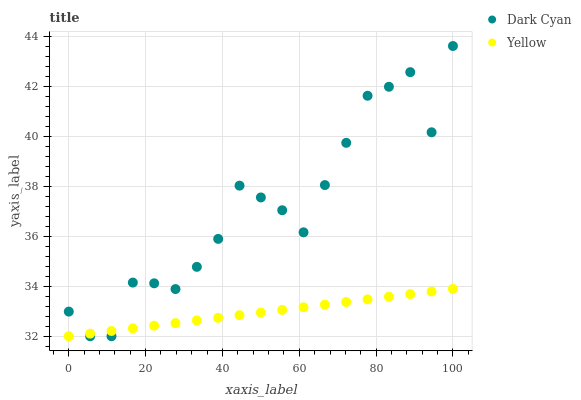Does Yellow have the minimum area under the curve?
Answer yes or no. Yes. Does Dark Cyan have the maximum area under the curve?
Answer yes or no. Yes. Does Yellow have the maximum area under the curve?
Answer yes or no. No. Is Yellow the smoothest?
Answer yes or no. Yes. Is Dark Cyan the roughest?
Answer yes or no. Yes. Is Yellow the roughest?
Answer yes or no. No. Does Dark Cyan have the lowest value?
Answer yes or no. Yes. Does Dark Cyan have the highest value?
Answer yes or no. Yes. Does Yellow have the highest value?
Answer yes or no. No. Does Yellow intersect Dark Cyan?
Answer yes or no. Yes. Is Yellow less than Dark Cyan?
Answer yes or no. No. Is Yellow greater than Dark Cyan?
Answer yes or no. No. 